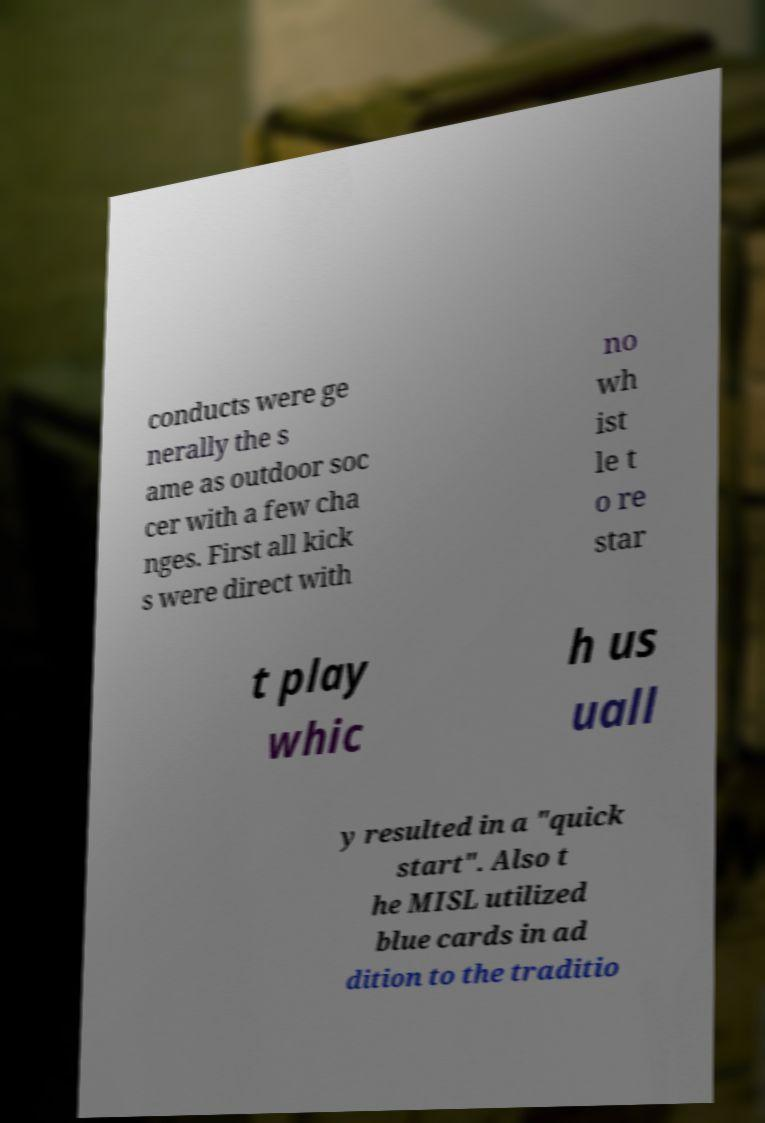Can you accurately transcribe the text from the provided image for me? conducts were ge nerally the s ame as outdoor soc cer with a few cha nges. First all kick s were direct with no wh ist le t o re star t play whic h us uall y resulted in a "quick start". Also t he MISL utilized blue cards in ad dition to the traditio 